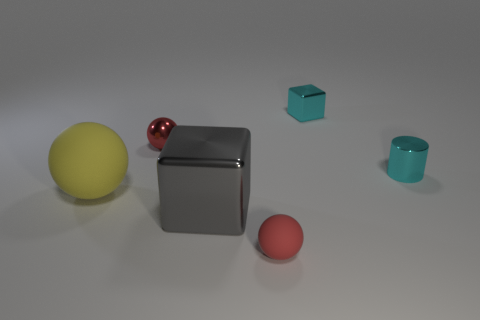Subtract all red spheres. How many spheres are left? 1 Subtract all brown cubes. How many red balls are left? 2 Add 3 big green shiny cylinders. How many objects exist? 9 Subtract all blocks. How many objects are left? 4 Subtract 2 red balls. How many objects are left? 4 Subtract all blue balls. Subtract all purple cylinders. How many balls are left? 3 Subtract all rubber things. Subtract all metal things. How many objects are left? 0 Add 2 yellow spheres. How many yellow spheres are left? 3 Add 3 small cylinders. How many small cylinders exist? 4 